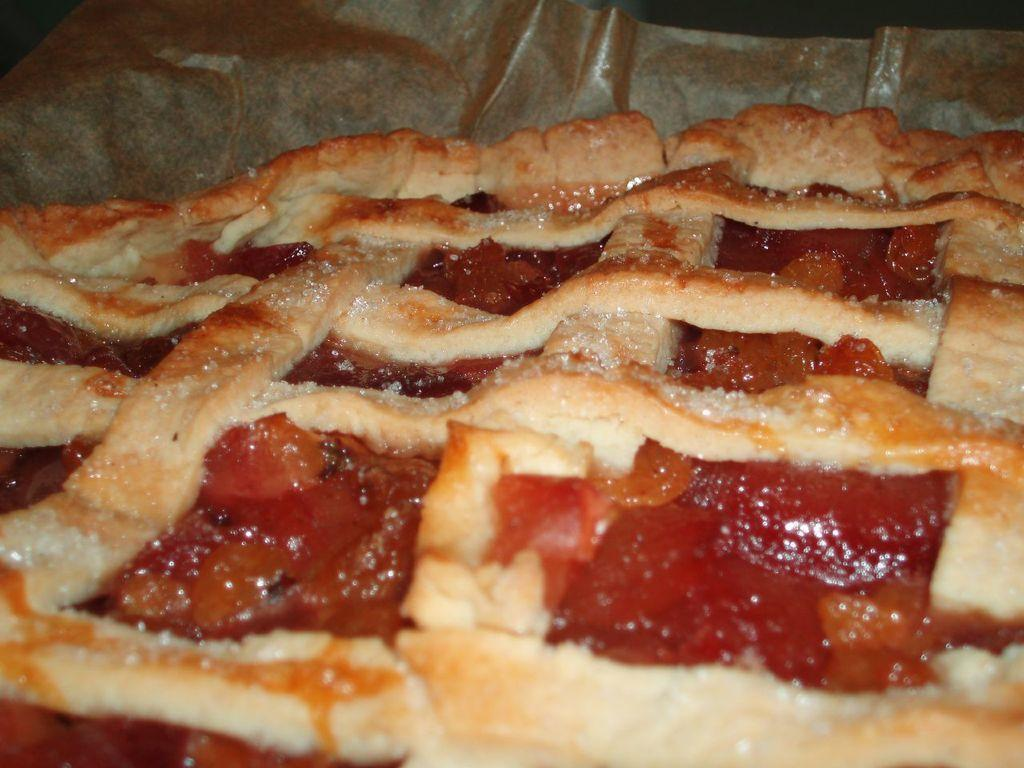What can be seen in the image related to food? There is food visible in the image. What type of disease is depicted in the image? There is no disease depicted in the image; it only shows food. Can you tell me how many tickets are visible in the image? There are no tickets present in the image. 